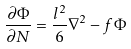Convert formula to latex. <formula><loc_0><loc_0><loc_500><loc_500>\frac { \partial \Phi } { \partial N } = \frac { l ^ { 2 } } { 6 } \nabla ^ { 2 } - f \Phi</formula> 